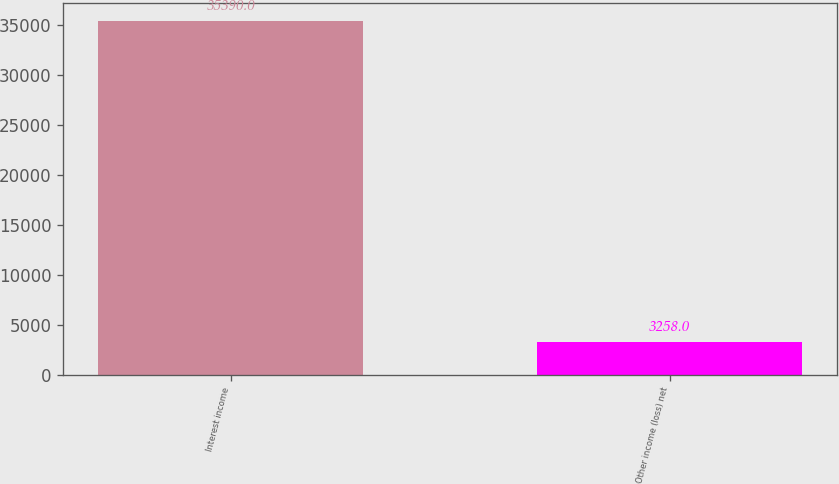<chart> <loc_0><loc_0><loc_500><loc_500><bar_chart><fcel>Interest income<fcel>Other income (loss) net<nl><fcel>35390<fcel>3258<nl></chart> 